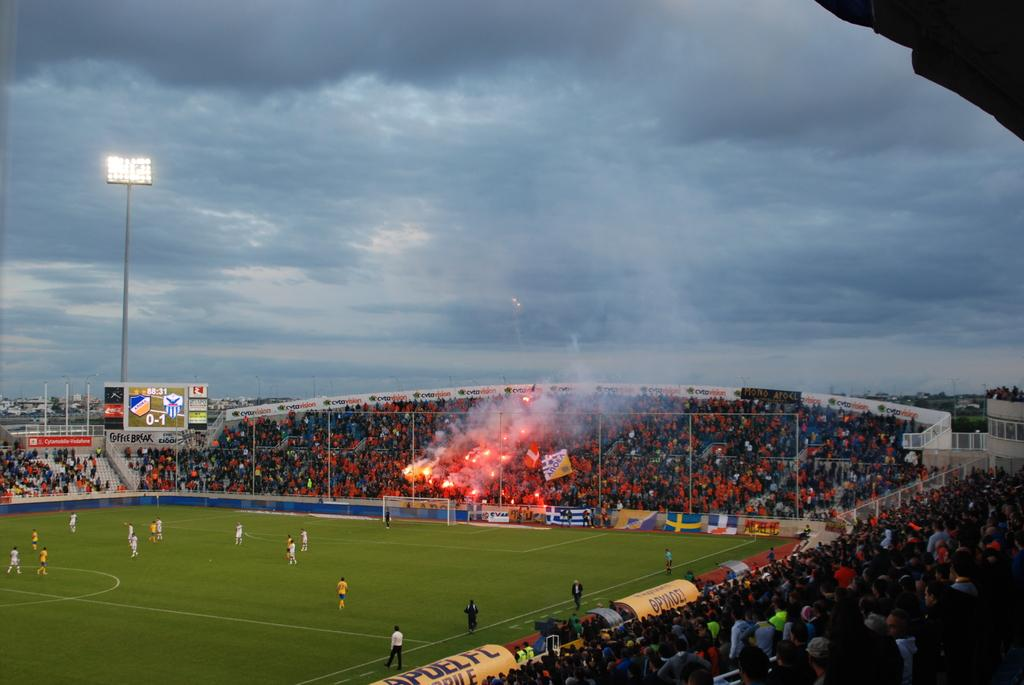<image>
Share a concise interpretation of the image provided. The scoreboard in the stadium shows that the score is currently 0-1. 